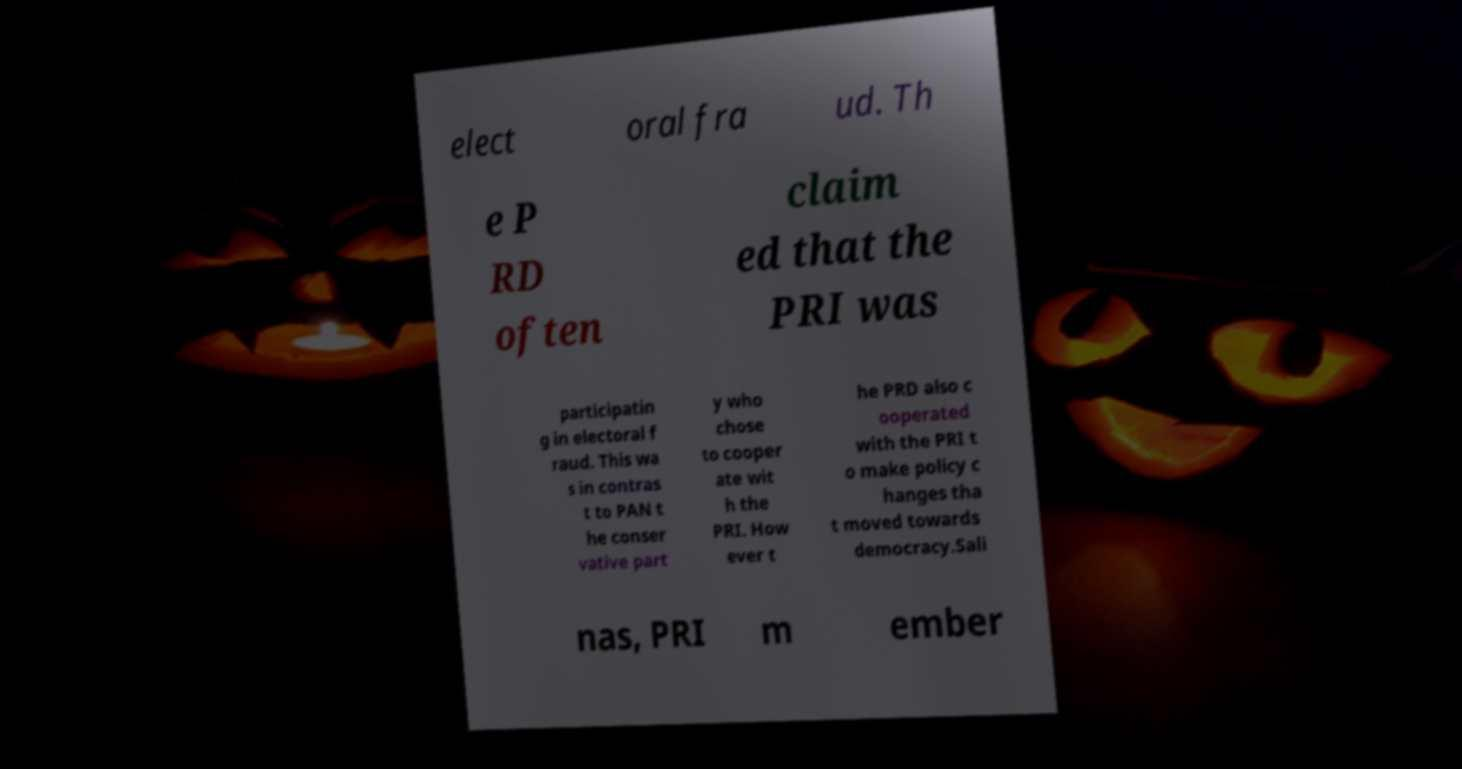Can you read and provide the text displayed in the image?This photo seems to have some interesting text. Can you extract and type it out for me? elect oral fra ud. Th e P RD often claim ed that the PRI was participatin g in electoral f raud. This wa s in contras t to PAN t he conser vative part y who chose to cooper ate wit h the PRI. How ever t he PRD also c ooperated with the PRI t o make policy c hanges tha t moved towards democracy.Sali nas, PRI m ember 